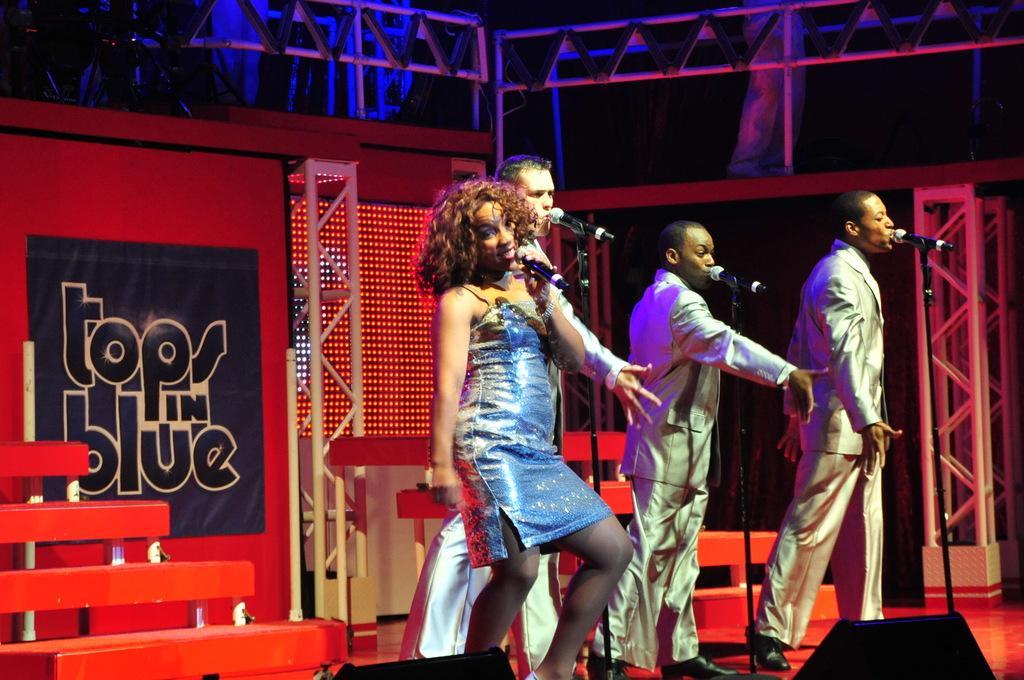Describe this image in one or two sentences. In this image we can see four men standing on the stage singing and dancing. There is one black board with text attached to the red wall, two objects on the floor, three microphones with stands on the stage, some poles, some iron rods, two red objects with poles on the stage looks like staircases, top of the image is dark, one person's legs and some objects on the floor. There is one woman holding a microphone standing, singing and dancing. 